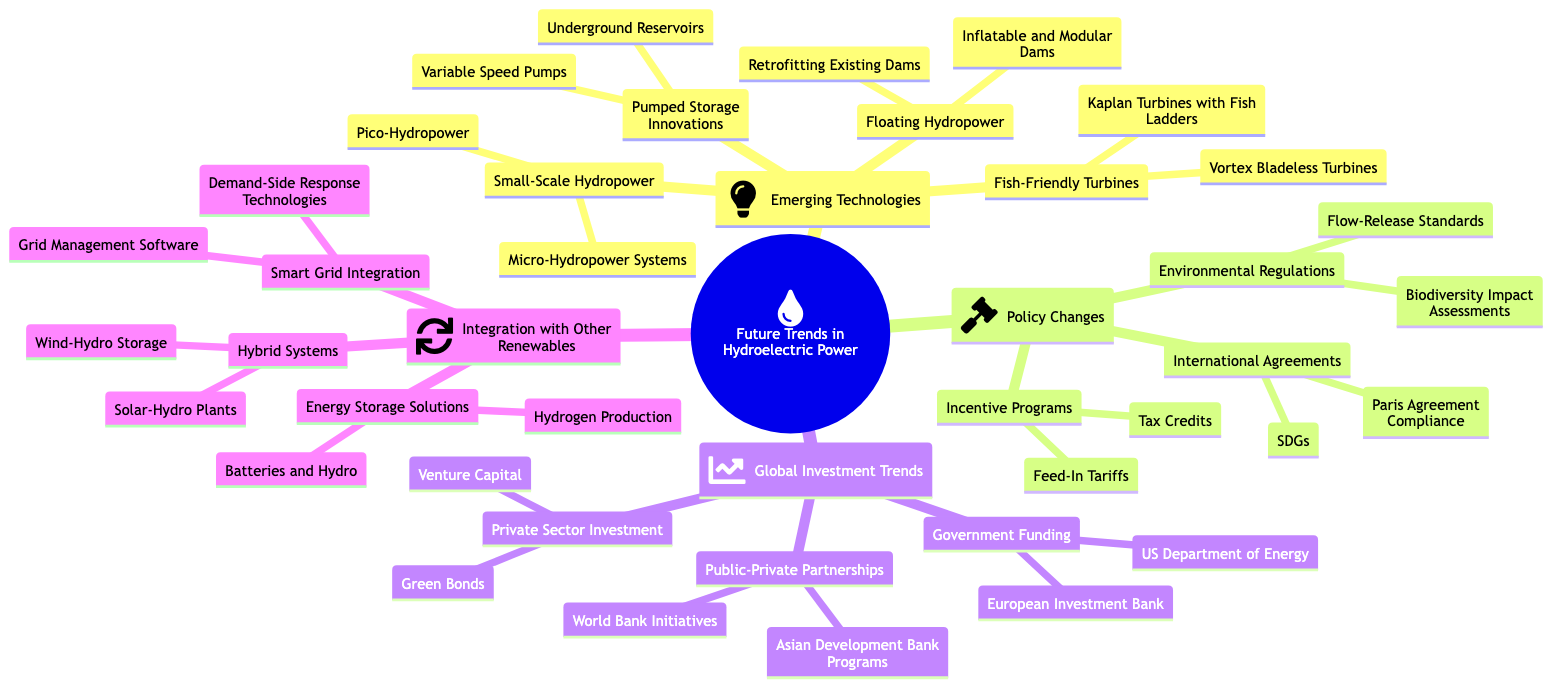What are the two types of small-scale hydropower mentioned? The diagram lists "Micro-Hydropower Systems" and "Pico-Hydropower" under the subtopic of "Small-Scale Hydropower."
Answer: Micro-Hydropower Systems, Pico-Hydropower How many entities are listed under Fish-Friendly Turbines? There are two entities listed under "Fish-Friendly Turbines": "Vortex Bladeless Turbines" and "Kaplan Turbines with Fish Ladders."
Answer: 2 Which government body is associated with funding in the Global Investment Trends section? The entity "US Department of Energy" is listed under "Government Funding," which is associated with global investment trends.
Answer: US Department of Energy What type of integration is mentioned alongside Hybrid Systems? The diagram mentions "Smart Grid Integration" as a related subtopic next to Hybrid Systems, indicating a focus on combining different energy systems.
Answer: Smart Grid Integration What are the two types of energy storage solutions listed in the Integration with Other Renewables section? The entities "Batteries and Hydro" and "Hydrogen Production" are mentioned under the "Energy Storage Solutions" subtopic.
Answer: Batteries and Hydro, Hydrogen Production Which kind of turbine is designed to be fish-friendly? "Vortex Bladeless Turbines" is one of the types of turbines specified as fish-friendly within the "Fish-Friendly Turbines" subtopic.
Answer: Vortex Bladeless Turbines What influences do international agreements have in the context of hydroelectric power? The diagram shows that "Paris Agreement Compliance" and "Sustainable Development Goals (SDGs)" are part of the "International Agreements" impacting hydroelectric power policies.
Answer: Paris Agreement Compliance, SDGs What innovative feature is associated with pumped storage in emerging technologies? "Variable Speed Pumps" is an innovative feature mentioned under "Pumped Storage Innovations."
Answer: Variable Speed Pumps How many subtopics fall under "Emerging Technologies"? The "Emerging Technologies" category contains four subtopics: "Small-Scale Hydropower," "Pumped Storage Innovations," "Floating Hydropower," and "Fish-Friendly Turbines," making a total of 4 subtopics.
Answer: 4 